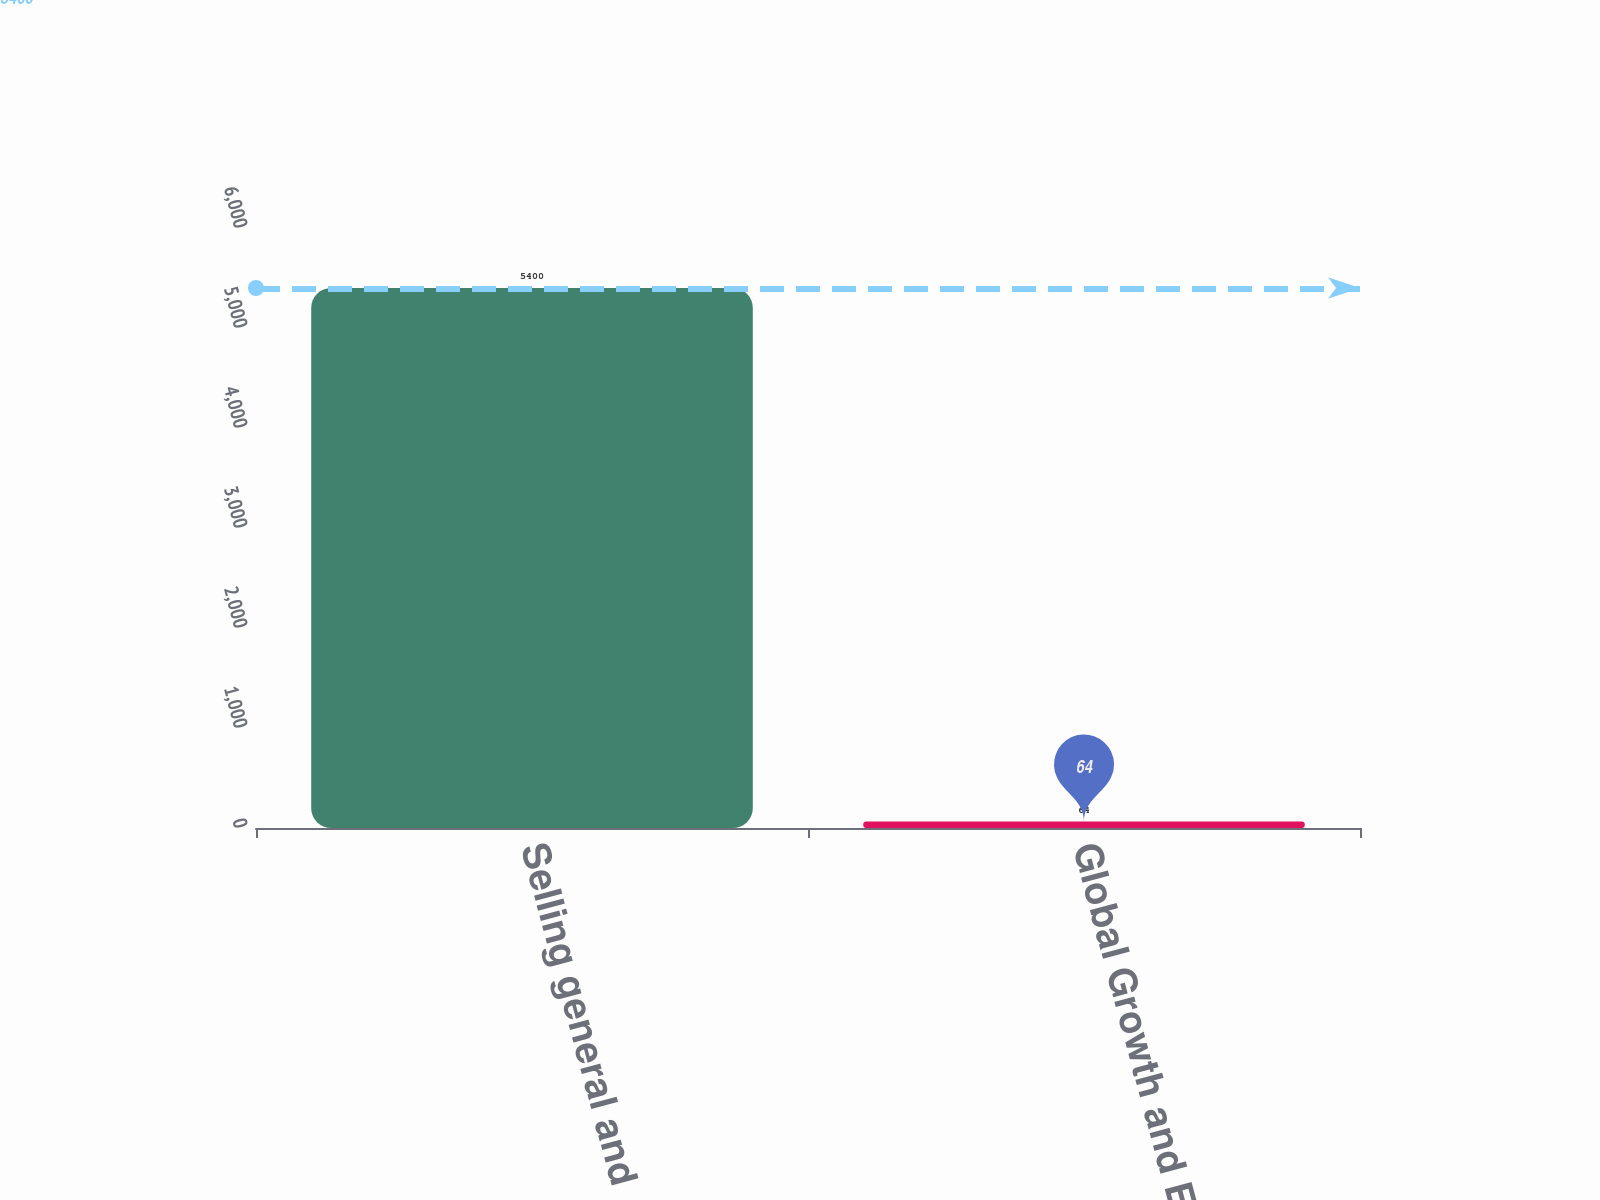<chart> <loc_0><loc_0><loc_500><loc_500><bar_chart><fcel>Selling general and<fcel>Global Growth and Efficiency<nl><fcel>5400<fcel>64<nl></chart> 